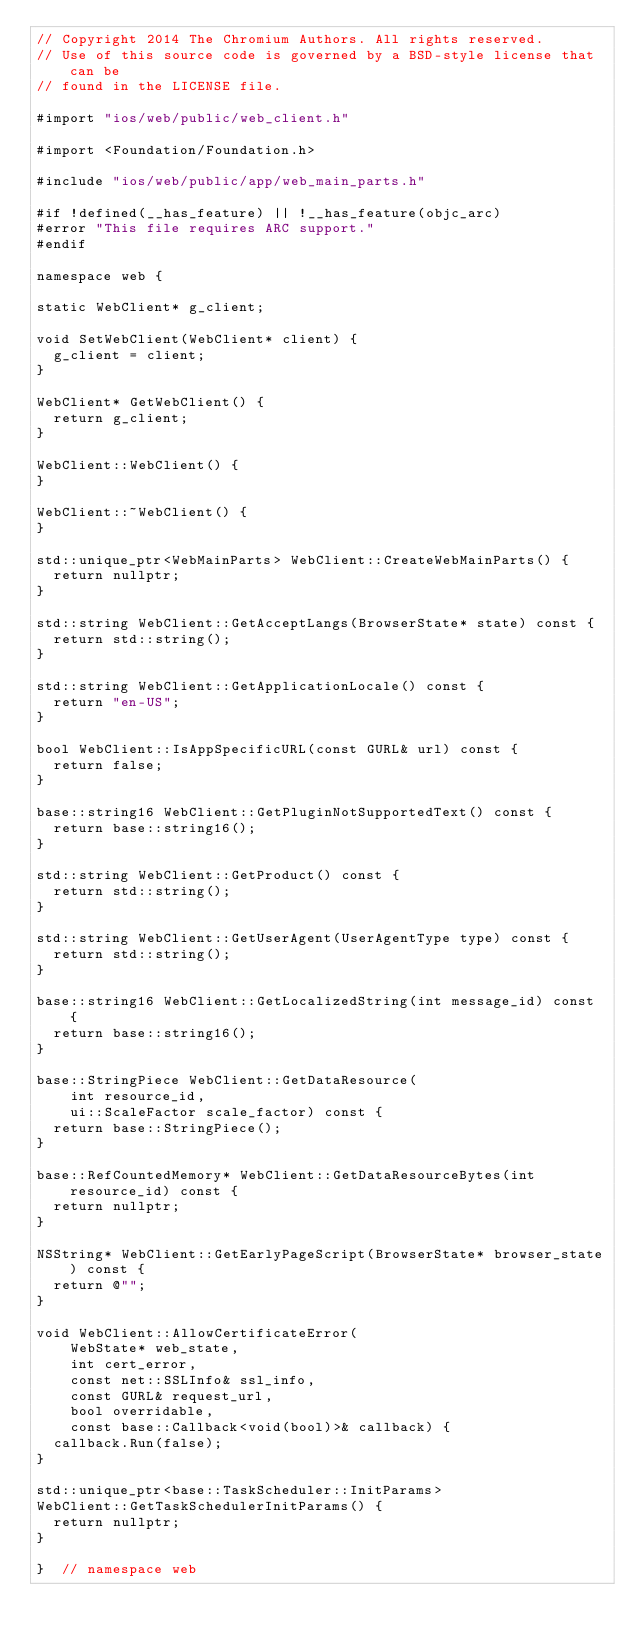<code> <loc_0><loc_0><loc_500><loc_500><_ObjectiveC_>// Copyright 2014 The Chromium Authors. All rights reserved.
// Use of this source code is governed by a BSD-style license that can be
// found in the LICENSE file.

#import "ios/web/public/web_client.h"

#import <Foundation/Foundation.h>

#include "ios/web/public/app/web_main_parts.h"

#if !defined(__has_feature) || !__has_feature(objc_arc)
#error "This file requires ARC support."
#endif

namespace web {

static WebClient* g_client;

void SetWebClient(WebClient* client) {
  g_client = client;
}

WebClient* GetWebClient() {
  return g_client;
}

WebClient::WebClient() {
}

WebClient::~WebClient() {
}

std::unique_ptr<WebMainParts> WebClient::CreateWebMainParts() {
  return nullptr;
}

std::string WebClient::GetAcceptLangs(BrowserState* state) const {
  return std::string();
}

std::string WebClient::GetApplicationLocale() const {
  return "en-US";
}

bool WebClient::IsAppSpecificURL(const GURL& url) const {
  return false;
}

base::string16 WebClient::GetPluginNotSupportedText() const {
  return base::string16();
}

std::string WebClient::GetProduct() const {
  return std::string();
}

std::string WebClient::GetUserAgent(UserAgentType type) const {
  return std::string();
}

base::string16 WebClient::GetLocalizedString(int message_id) const {
  return base::string16();
}

base::StringPiece WebClient::GetDataResource(
    int resource_id,
    ui::ScaleFactor scale_factor) const {
  return base::StringPiece();
}

base::RefCountedMemory* WebClient::GetDataResourceBytes(int resource_id) const {
  return nullptr;
}

NSString* WebClient::GetEarlyPageScript(BrowserState* browser_state) const {
  return @"";
}

void WebClient::AllowCertificateError(
    WebState* web_state,
    int cert_error,
    const net::SSLInfo& ssl_info,
    const GURL& request_url,
    bool overridable,
    const base::Callback<void(bool)>& callback) {
  callback.Run(false);
}

std::unique_ptr<base::TaskScheduler::InitParams>
WebClient::GetTaskSchedulerInitParams() {
  return nullptr;
}

}  // namespace web
</code> 